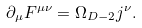<formula> <loc_0><loc_0><loc_500><loc_500>\partial _ { \mu } F ^ { \mu \nu } = \Omega _ { D - 2 } j ^ { \nu } .</formula> 